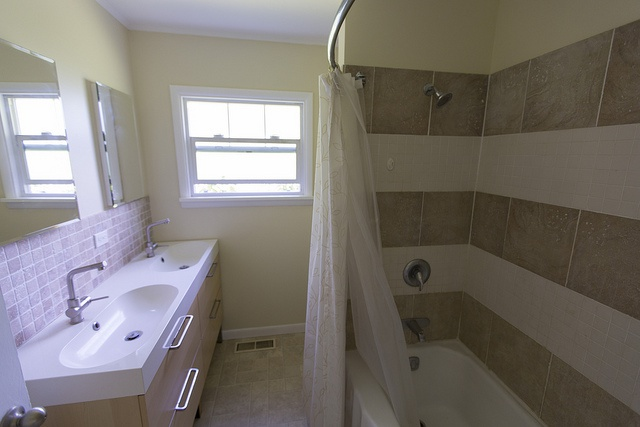Describe the objects in this image and their specific colors. I can see a sink in darkgray, lavender, and gray tones in this image. 